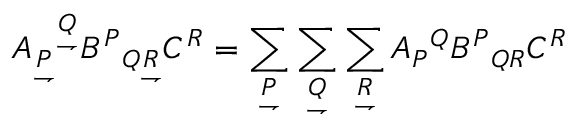Convert formula to latex. <formula><loc_0><loc_0><loc_500><loc_500>A _ { \underset { \rightharpoondown } { P } ^ { \underset { \rightharpoondown } { Q } } B ^ { P _ { Q { \underset { \rightharpoondown } { R } } } C ^ { R } = \sum _ { \underset { \rightharpoondown } { P } } \sum _ { \underset { \rightharpoondown } { Q } } \sum _ { \underset { \rightharpoondown } { R } } A _ { P ^ { Q } B ^ { P _ { Q R } C ^ { R }</formula> 